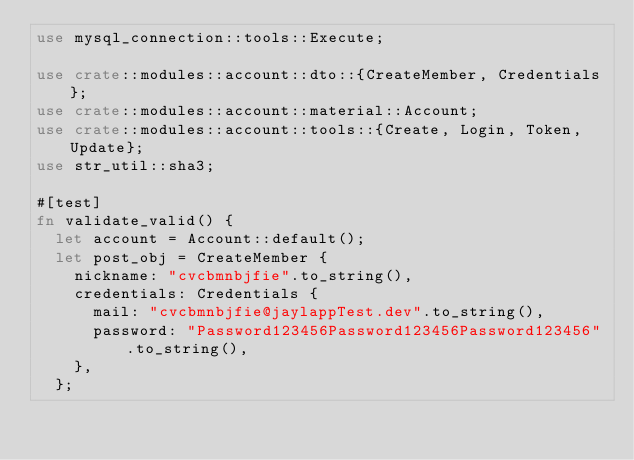Convert code to text. <code><loc_0><loc_0><loc_500><loc_500><_Rust_>use mysql_connection::tools::Execute;

use crate::modules::account::dto::{CreateMember, Credentials};
use crate::modules::account::material::Account;
use crate::modules::account::tools::{Create, Login, Token, Update};
use str_util::sha3;

#[test]
fn validate_valid() {
  let account = Account::default();
  let post_obj = CreateMember {
    nickname: "cvcbmnbjfie".to_string(),
    credentials: Credentials {
      mail: "cvcbmnbjfie@jaylappTest.dev".to_string(),
      password: "Password123456Password123456Password123456".to_string(),
    },
  };
</code> 